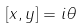<formula> <loc_0><loc_0><loc_500><loc_500>\left [ x , y \right ] = i \theta</formula> 